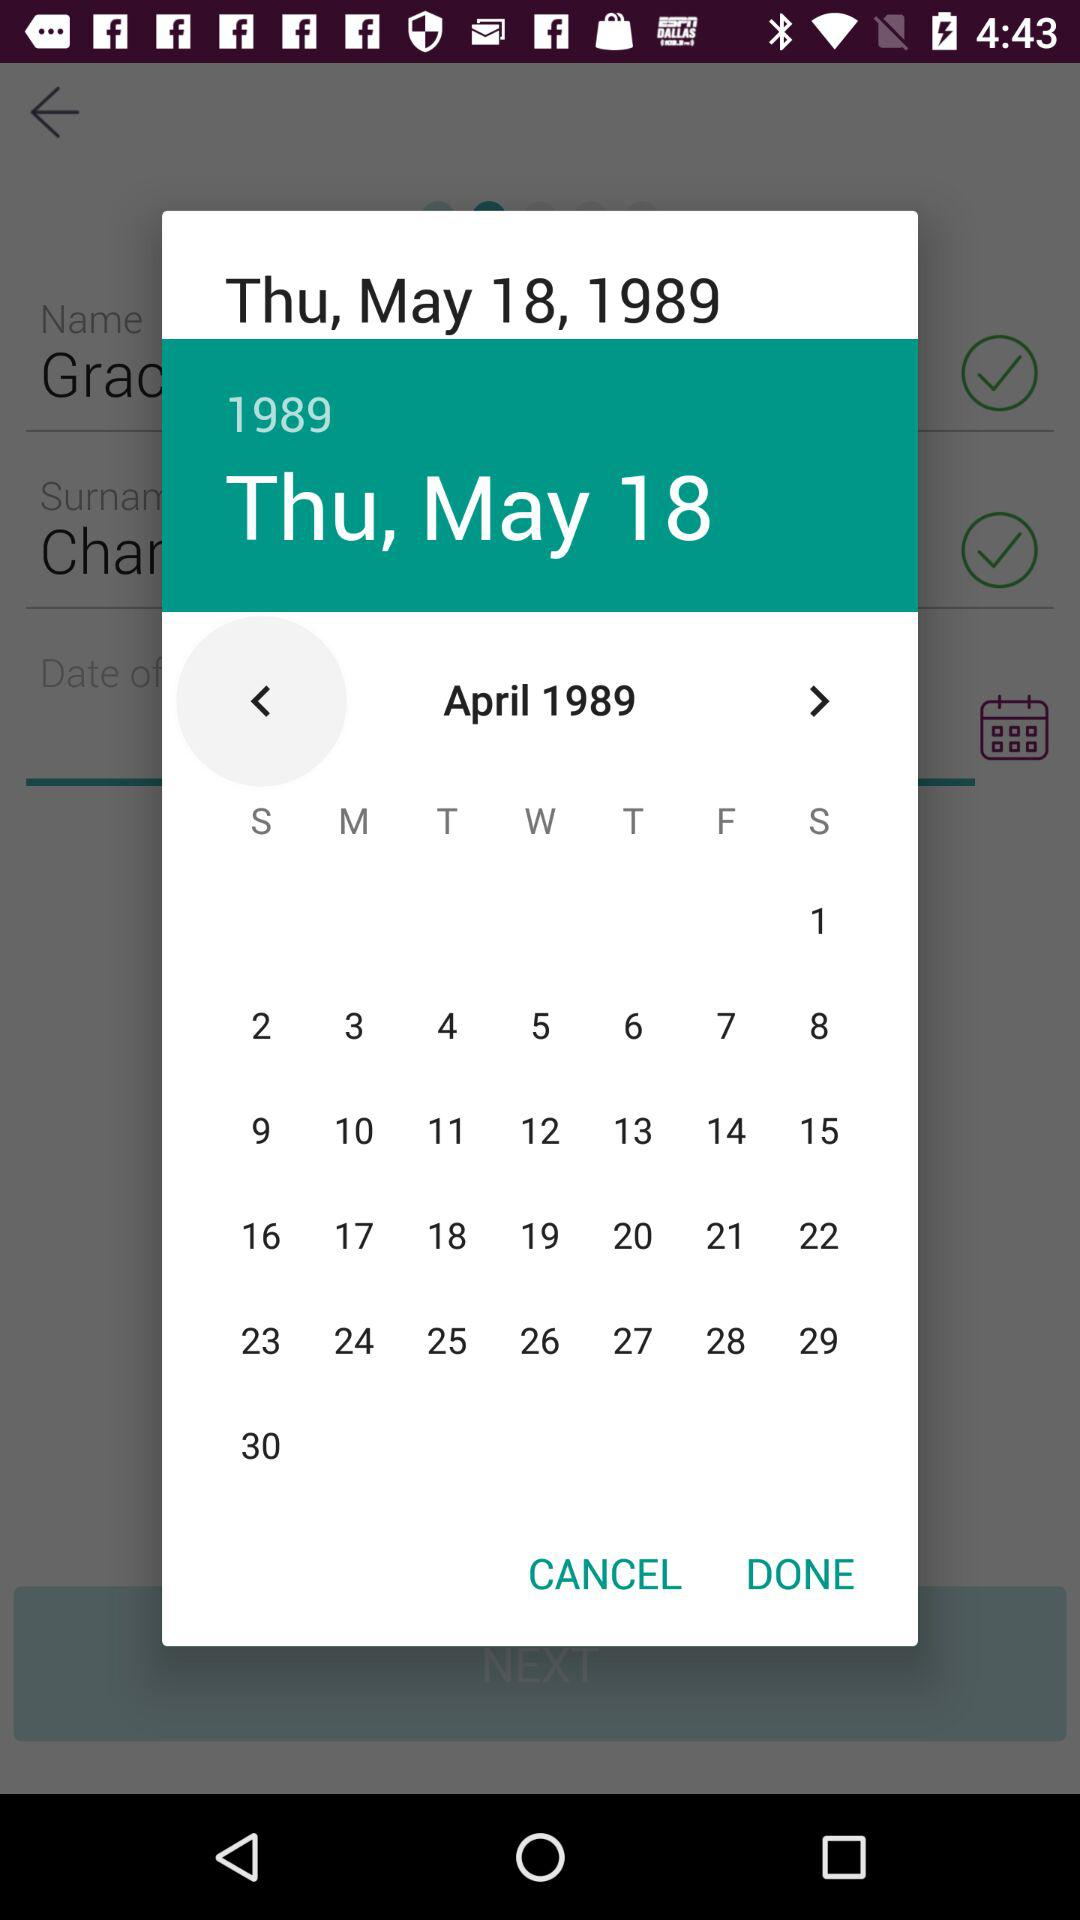What is the day on May 18? The day is Thursday. 